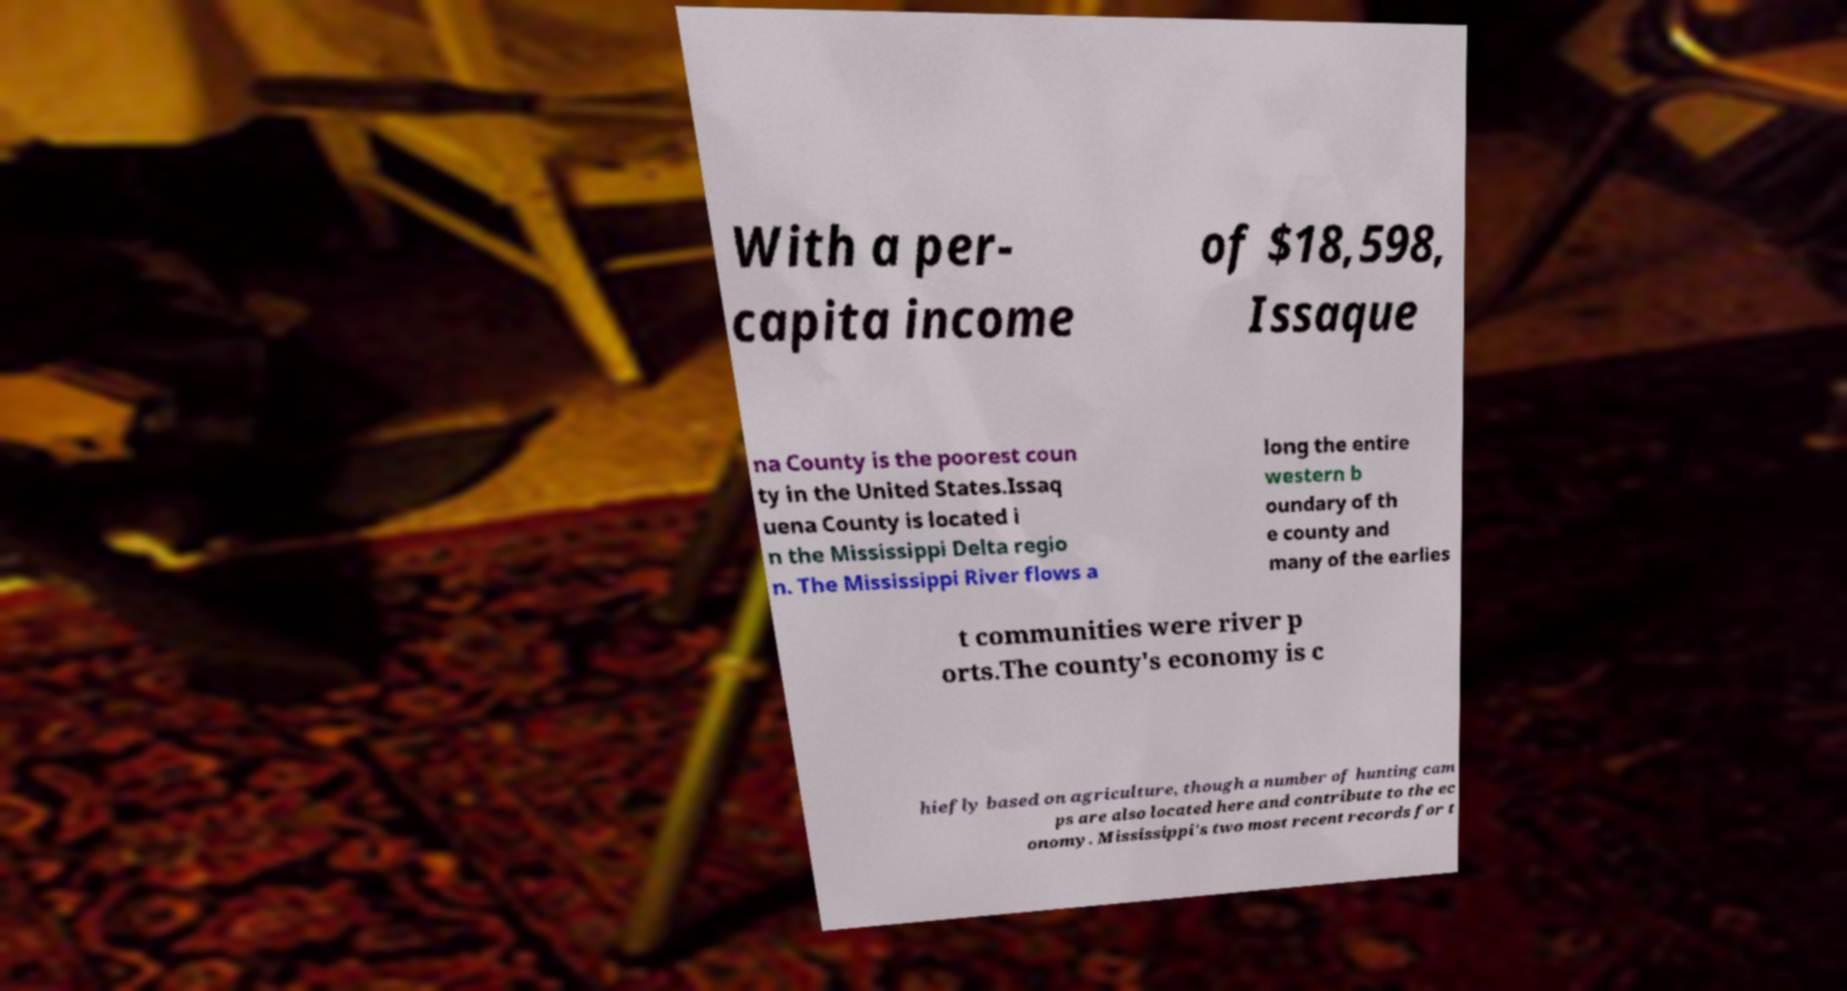Please identify and transcribe the text found in this image. With a per- capita income of $18,598, Issaque na County is the poorest coun ty in the United States.Issaq uena County is located i n the Mississippi Delta regio n. The Mississippi River flows a long the entire western b oundary of th e county and many of the earlies t communities were river p orts.The county's economy is c hiefly based on agriculture, though a number of hunting cam ps are also located here and contribute to the ec onomy. Mississippi's two most recent records for t 